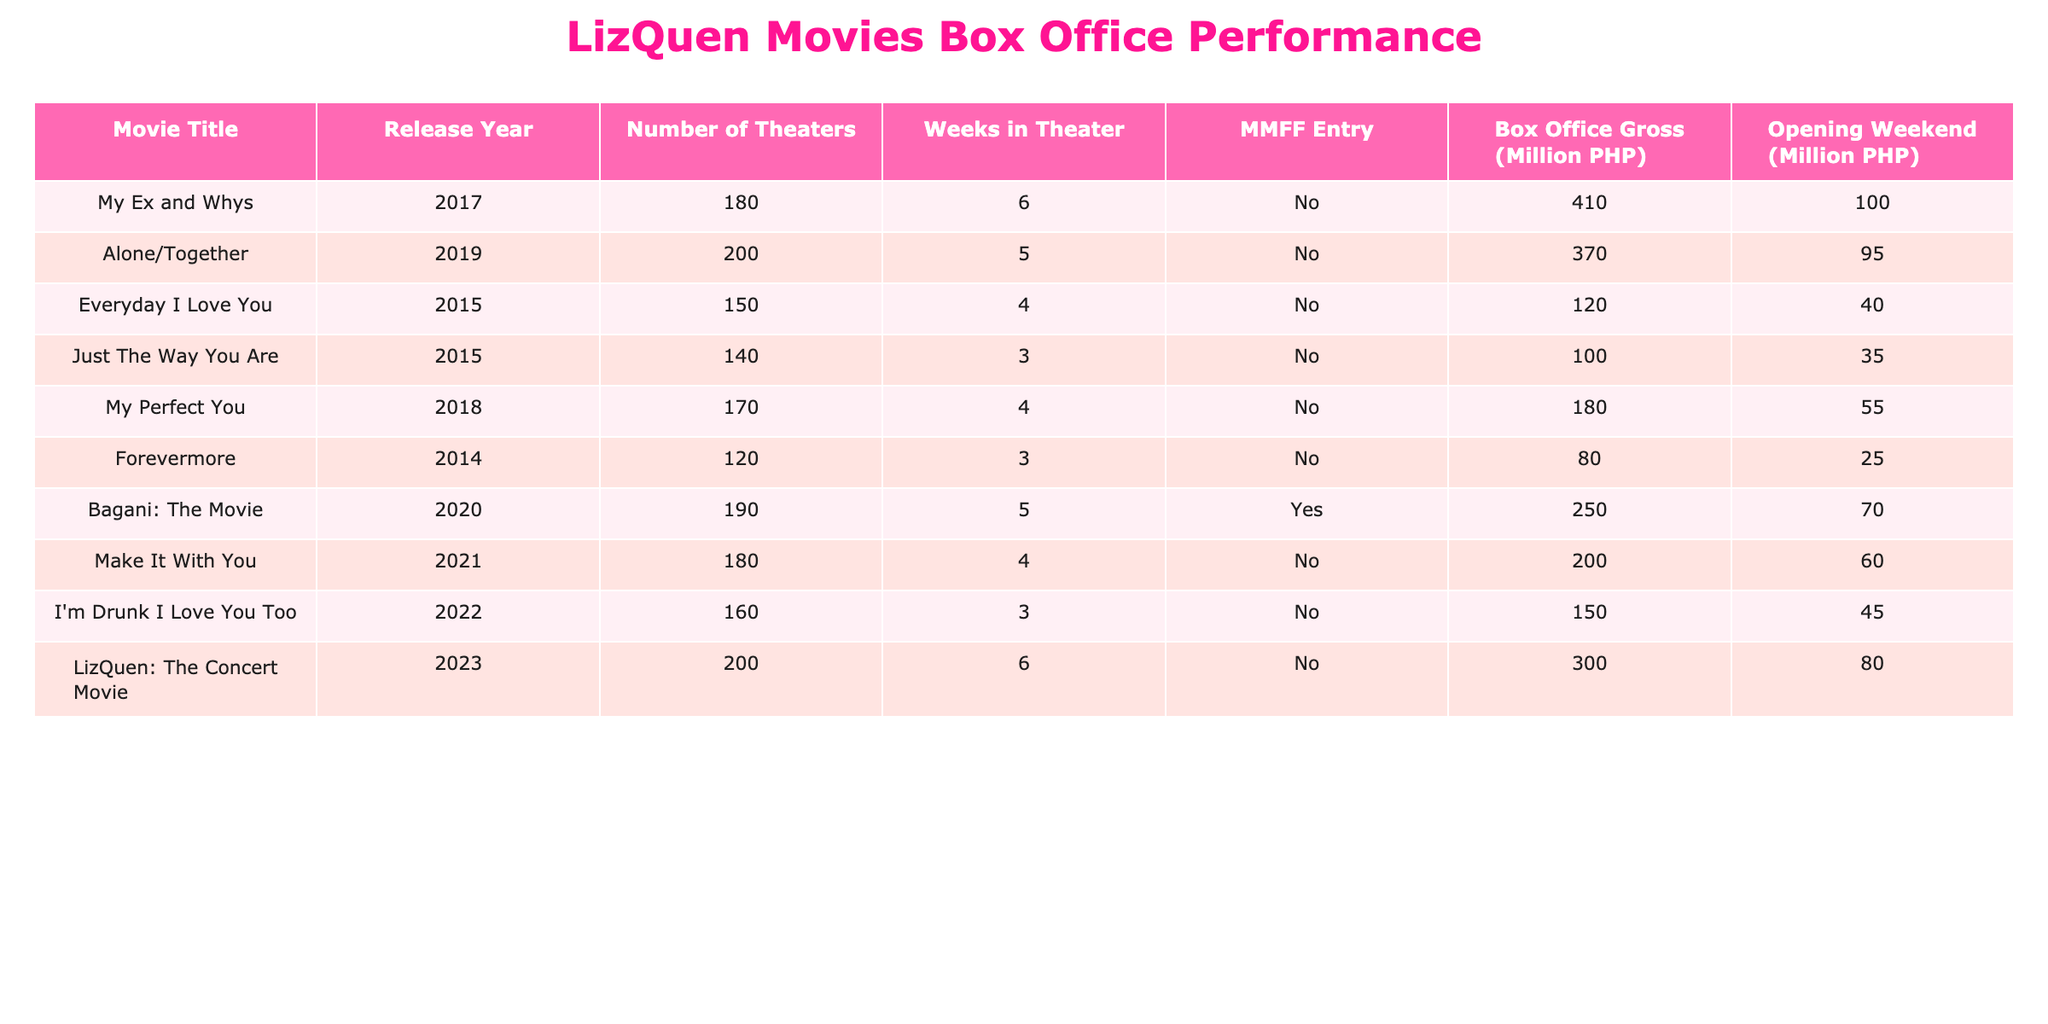What is the highest box office gross among LizQuen movies? Looking at the "Box Office Gross (PHP)" column, the movie "My Ex and Whys" has the highest value of 410000000 PHP.
Answer: 410000000 PHP Which movie had the highest opening weekend revenue? Checking the "Opening Weekend (PHP)" column, "My Ex and Whys" had the highest opening weekend revenue of 100000000 PHP, which can be confirmed by comparing the values in that column.
Answer: 100000000 PHP How many weeks did "Alone/Together" spend in theaters? Referring to the "Weeks in Theater" column, "Alone/Together" spent 5 weeks in theaters.
Answer: 5 weeks What is the average box office gross of all movies listed in the table? To find the average, sum all the box office gross values: 410000000 + 370000000 + 120000000 + 100000000 + 180000000 + 80000000 + 250000000 + 200000000 + 150000000 + 300000000 = 1910000000 PHP. There are 10 movies, so the average is 1910000000 PHP / 10 = 191000000 PHP.
Answer: 191000000 PHP Did "Bagani: The Movie" participate in the MMFF? By checking the "MMFF Entry" column, it shows "Yes" for "Bagani: The Movie," confirming that it participated in the MMFF.
Answer: Yes What is the difference in box office gross between "My Perfect You" and "Everyday I Love You"? The box office gross for "My Perfect You" is 180000000 PHP, and for "Everyday I Love You" it is 120000000 PHP. The difference is 180000000 PHP - 120000000 PHP = 60000000 PHP.
Answer: 60000000 PHP Which two movies had the lowest box office gross? By comparing the box office gross values, "Forevermore" with 80000000 PHP and "Just The Way You Are" with 100000000 PHP are the two movies with the lowest gross.
Answer: Forevermore and Just The Way You Are What were the opening weekend numbers of the two highest-grossing films? "My Ex and Whys" had an opening weekend of 100000000 PHP, while "LizQuen: The Concert Movie" had an opening weekend of 80000000 PHP.
Answer: 100000000 PHP and 80000000 PHP What percentage of the gross was generated during the opening weekend for "I'm Drunk I Love You Too"? The box office gross is 150000000 PHP and the opening weekend gross is 45000000 PHP. The percentage is (45000000 PHP / 150000000 PHP) * 100 = 30%.
Answer: 30% 